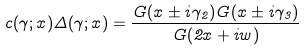<formula> <loc_0><loc_0><loc_500><loc_500>c ( \gamma ; x ) \Delta ( \gamma ; x ) = \frac { G ( x \pm i \gamma _ { 2 } ) G ( x \pm i \gamma _ { 3 } ) } { G ( 2 x + i w ) }</formula> 